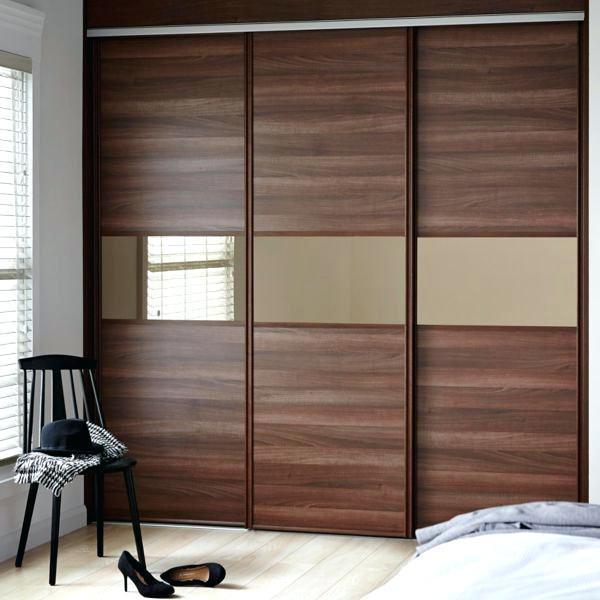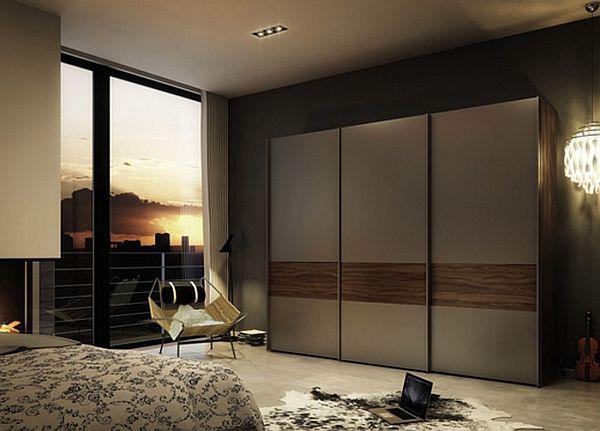The first image is the image on the left, the second image is the image on the right. Analyze the images presented: Is the assertion "Both closets are closed." valid? Answer yes or no. Yes. The first image is the image on the left, the second image is the image on the right. Assess this claim about the two images: "The left image shows a unit with three sliding doors and a band across the front surrounded by a brown top and bottom.". Correct or not? Answer yes or no. Yes. 